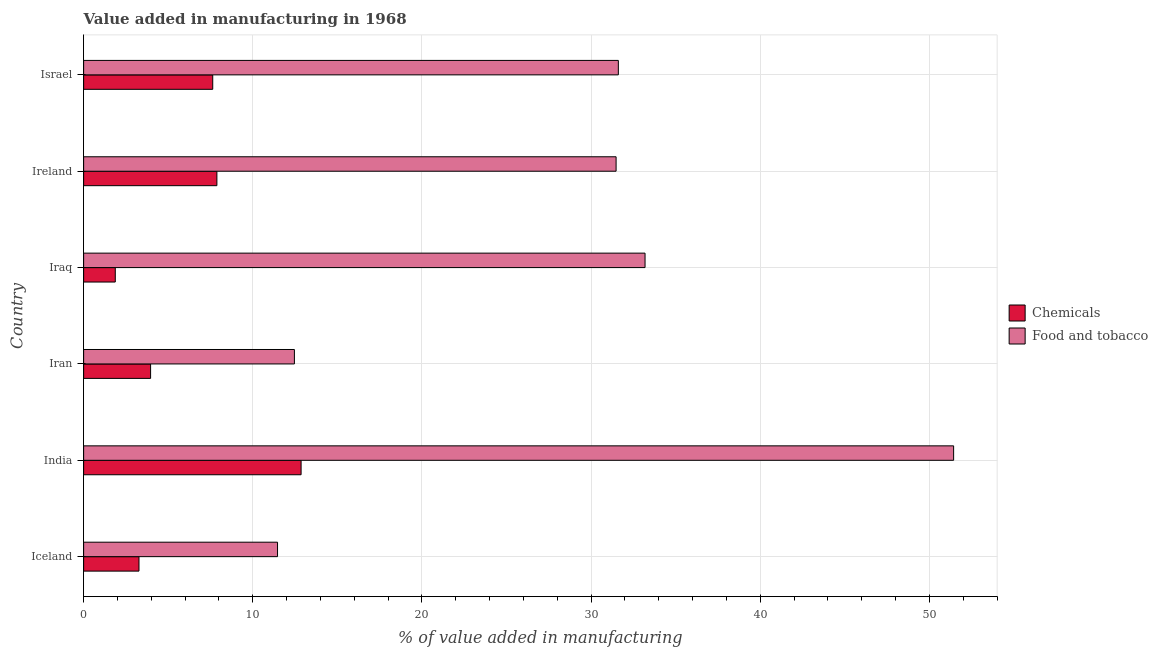How many different coloured bars are there?
Your answer should be very brief. 2. What is the label of the 1st group of bars from the top?
Keep it short and to the point. Israel. In how many cases, is the number of bars for a given country not equal to the number of legend labels?
Keep it short and to the point. 0. What is the value added by manufacturing food and tobacco in Israel?
Offer a very short reply. 31.61. Across all countries, what is the maximum value added by  manufacturing chemicals?
Give a very brief answer. 12.86. Across all countries, what is the minimum value added by  manufacturing chemicals?
Make the answer very short. 1.87. In which country was the value added by  manufacturing chemicals maximum?
Offer a terse response. India. What is the total value added by manufacturing food and tobacco in the graph?
Your answer should be very brief. 171.64. What is the difference between the value added by manufacturing food and tobacco in Iran and that in Israel?
Provide a succinct answer. -19.15. What is the difference between the value added by  manufacturing chemicals in Israel and the value added by manufacturing food and tobacco in Iceland?
Make the answer very short. -3.83. What is the average value added by  manufacturing chemicals per country?
Offer a very short reply. 6.25. What is the difference between the value added by manufacturing food and tobacco and value added by  manufacturing chemicals in Iran?
Your response must be concise. 8.5. What is the ratio of the value added by  manufacturing chemicals in India to that in Iraq?
Provide a succinct answer. 6.87. What is the difference between the highest and the second highest value added by  manufacturing chemicals?
Offer a very short reply. 4.98. What is the difference between the highest and the lowest value added by manufacturing food and tobacco?
Give a very brief answer. 39.97. In how many countries, is the value added by  manufacturing chemicals greater than the average value added by  manufacturing chemicals taken over all countries?
Offer a terse response. 3. Is the sum of the value added by manufacturing food and tobacco in Iceland and Israel greater than the maximum value added by  manufacturing chemicals across all countries?
Provide a succinct answer. Yes. What does the 2nd bar from the top in Iceland represents?
Give a very brief answer. Chemicals. What does the 2nd bar from the bottom in Israel represents?
Offer a very short reply. Food and tobacco. How many bars are there?
Provide a succinct answer. 12. Are all the bars in the graph horizontal?
Your answer should be very brief. Yes. How many countries are there in the graph?
Ensure brevity in your answer.  6. What is the difference between two consecutive major ticks on the X-axis?
Keep it short and to the point. 10. Are the values on the major ticks of X-axis written in scientific E-notation?
Offer a terse response. No. Does the graph contain any zero values?
Make the answer very short. No. Does the graph contain grids?
Your answer should be compact. Yes. Where does the legend appear in the graph?
Make the answer very short. Center right. How many legend labels are there?
Offer a very short reply. 2. How are the legend labels stacked?
Keep it short and to the point. Vertical. What is the title of the graph?
Ensure brevity in your answer.  Value added in manufacturing in 1968. What is the label or title of the X-axis?
Keep it short and to the point. % of value added in manufacturing. What is the label or title of the Y-axis?
Keep it short and to the point. Country. What is the % of value added in manufacturing in Chemicals in Iceland?
Make the answer very short. 3.27. What is the % of value added in manufacturing in Food and tobacco in Iceland?
Your answer should be compact. 11.46. What is the % of value added in manufacturing of Chemicals in India?
Give a very brief answer. 12.86. What is the % of value added in manufacturing of Food and tobacco in India?
Your answer should be compact. 51.43. What is the % of value added in manufacturing in Chemicals in Iran?
Provide a short and direct response. 3.96. What is the % of value added in manufacturing in Food and tobacco in Iran?
Make the answer very short. 12.46. What is the % of value added in manufacturing of Chemicals in Iraq?
Make the answer very short. 1.87. What is the % of value added in manufacturing in Food and tobacco in Iraq?
Provide a succinct answer. 33.19. What is the % of value added in manufacturing of Chemicals in Ireland?
Give a very brief answer. 7.88. What is the % of value added in manufacturing in Food and tobacco in Ireland?
Provide a short and direct response. 31.48. What is the % of value added in manufacturing of Chemicals in Israel?
Offer a very short reply. 7.63. What is the % of value added in manufacturing of Food and tobacco in Israel?
Provide a succinct answer. 31.61. Across all countries, what is the maximum % of value added in manufacturing of Chemicals?
Your response must be concise. 12.86. Across all countries, what is the maximum % of value added in manufacturing in Food and tobacco?
Offer a very short reply. 51.43. Across all countries, what is the minimum % of value added in manufacturing of Chemicals?
Provide a succinct answer. 1.87. Across all countries, what is the minimum % of value added in manufacturing of Food and tobacco?
Ensure brevity in your answer.  11.46. What is the total % of value added in manufacturing in Chemicals in the graph?
Ensure brevity in your answer.  37.47. What is the total % of value added in manufacturing in Food and tobacco in the graph?
Provide a short and direct response. 171.64. What is the difference between the % of value added in manufacturing in Chemicals in Iceland and that in India?
Your response must be concise. -9.58. What is the difference between the % of value added in manufacturing of Food and tobacco in Iceland and that in India?
Give a very brief answer. -39.97. What is the difference between the % of value added in manufacturing in Chemicals in Iceland and that in Iran?
Your answer should be very brief. -0.69. What is the difference between the % of value added in manufacturing of Food and tobacco in Iceland and that in Iran?
Your response must be concise. -1. What is the difference between the % of value added in manufacturing in Chemicals in Iceland and that in Iraq?
Your answer should be very brief. 1.4. What is the difference between the % of value added in manufacturing in Food and tobacco in Iceland and that in Iraq?
Give a very brief answer. -21.73. What is the difference between the % of value added in manufacturing in Chemicals in Iceland and that in Ireland?
Keep it short and to the point. -4.61. What is the difference between the % of value added in manufacturing of Food and tobacco in Iceland and that in Ireland?
Offer a terse response. -20.02. What is the difference between the % of value added in manufacturing of Chemicals in Iceland and that in Israel?
Your answer should be compact. -4.36. What is the difference between the % of value added in manufacturing of Food and tobacco in Iceland and that in Israel?
Give a very brief answer. -20.15. What is the difference between the % of value added in manufacturing of Chemicals in India and that in Iran?
Your response must be concise. 8.9. What is the difference between the % of value added in manufacturing in Food and tobacco in India and that in Iran?
Make the answer very short. 38.97. What is the difference between the % of value added in manufacturing in Chemicals in India and that in Iraq?
Give a very brief answer. 10.98. What is the difference between the % of value added in manufacturing in Food and tobacco in India and that in Iraq?
Offer a very short reply. 18.24. What is the difference between the % of value added in manufacturing in Chemicals in India and that in Ireland?
Offer a terse response. 4.98. What is the difference between the % of value added in manufacturing of Food and tobacco in India and that in Ireland?
Offer a very short reply. 19.95. What is the difference between the % of value added in manufacturing in Chemicals in India and that in Israel?
Your answer should be very brief. 5.22. What is the difference between the % of value added in manufacturing of Food and tobacco in India and that in Israel?
Provide a succinct answer. 19.82. What is the difference between the % of value added in manufacturing of Chemicals in Iran and that in Iraq?
Ensure brevity in your answer.  2.09. What is the difference between the % of value added in manufacturing in Food and tobacco in Iran and that in Iraq?
Ensure brevity in your answer.  -20.73. What is the difference between the % of value added in manufacturing of Chemicals in Iran and that in Ireland?
Provide a short and direct response. -3.92. What is the difference between the % of value added in manufacturing of Food and tobacco in Iran and that in Ireland?
Keep it short and to the point. -19.02. What is the difference between the % of value added in manufacturing of Chemicals in Iran and that in Israel?
Give a very brief answer. -3.67. What is the difference between the % of value added in manufacturing in Food and tobacco in Iran and that in Israel?
Offer a terse response. -19.15. What is the difference between the % of value added in manufacturing of Chemicals in Iraq and that in Ireland?
Your response must be concise. -6.01. What is the difference between the % of value added in manufacturing of Food and tobacco in Iraq and that in Ireland?
Ensure brevity in your answer.  1.71. What is the difference between the % of value added in manufacturing of Chemicals in Iraq and that in Israel?
Provide a succinct answer. -5.76. What is the difference between the % of value added in manufacturing of Food and tobacco in Iraq and that in Israel?
Keep it short and to the point. 1.58. What is the difference between the % of value added in manufacturing of Chemicals in Ireland and that in Israel?
Make the answer very short. 0.25. What is the difference between the % of value added in manufacturing of Food and tobacco in Ireland and that in Israel?
Your answer should be very brief. -0.13. What is the difference between the % of value added in manufacturing in Chemicals in Iceland and the % of value added in manufacturing in Food and tobacco in India?
Provide a short and direct response. -48.16. What is the difference between the % of value added in manufacturing of Chemicals in Iceland and the % of value added in manufacturing of Food and tobacco in Iran?
Give a very brief answer. -9.19. What is the difference between the % of value added in manufacturing of Chemicals in Iceland and the % of value added in manufacturing of Food and tobacco in Iraq?
Ensure brevity in your answer.  -29.92. What is the difference between the % of value added in manufacturing in Chemicals in Iceland and the % of value added in manufacturing in Food and tobacco in Ireland?
Provide a short and direct response. -28.21. What is the difference between the % of value added in manufacturing of Chemicals in Iceland and the % of value added in manufacturing of Food and tobacco in Israel?
Make the answer very short. -28.34. What is the difference between the % of value added in manufacturing of Chemicals in India and the % of value added in manufacturing of Food and tobacco in Iran?
Your response must be concise. 0.4. What is the difference between the % of value added in manufacturing of Chemicals in India and the % of value added in manufacturing of Food and tobacco in Iraq?
Provide a succinct answer. -20.33. What is the difference between the % of value added in manufacturing in Chemicals in India and the % of value added in manufacturing in Food and tobacco in Ireland?
Your answer should be very brief. -18.62. What is the difference between the % of value added in manufacturing of Chemicals in India and the % of value added in manufacturing of Food and tobacco in Israel?
Keep it short and to the point. -18.76. What is the difference between the % of value added in manufacturing in Chemicals in Iran and the % of value added in manufacturing in Food and tobacco in Iraq?
Make the answer very short. -29.23. What is the difference between the % of value added in manufacturing in Chemicals in Iran and the % of value added in manufacturing in Food and tobacco in Ireland?
Keep it short and to the point. -27.52. What is the difference between the % of value added in manufacturing of Chemicals in Iran and the % of value added in manufacturing of Food and tobacco in Israel?
Your answer should be compact. -27.65. What is the difference between the % of value added in manufacturing of Chemicals in Iraq and the % of value added in manufacturing of Food and tobacco in Ireland?
Your response must be concise. -29.61. What is the difference between the % of value added in manufacturing of Chemicals in Iraq and the % of value added in manufacturing of Food and tobacco in Israel?
Your answer should be compact. -29.74. What is the difference between the % of value added in manufacturing of Chemicals in Ireland and the % of value added in manufacturing of Food and tobacco in Israel?
Your response must be concise. -23.73. What is the average % of value added in manufacturing in Chemicals per country?
Make the answer very short. 6.25. What is the average % of value added in manufacturing in Food and tobacco per country?
Make the answer very short. 28.61. What is the difference between the % of value added in manufacturing in Chemicals and % of value added in manufacturing in Food and tobacco in Iceland?
Provide a succinct answer. -8.19. What is the difference between the % of value added in manufacturing of Chemicals and % of value added in manufacturing of Food and tobacco in India?
Offer a terse response. -38.58. What is the difference between the % of value added in manufacturing of Chemicals and % of value added in manufacturing of Food and tobacco in Iran?
Give a very brief answer. -8.5. What is the difference between the % of value added in manufacturing in Chemicals and % of value added in manufacturing in Food and tobacco in Iraq?
Provide a succinct answer. -31.32. What is the difference between the % of value added in manufacturing in Chemicals and % of value added in manufacturing in Food and tobacco in Ireland?
Offer a very short reply. -23.6. What is the difference between the % of value added in manufacturing of Chemicals and % of value added in manufacturing of Food and tobacco in Israel?
Offer a very short reply. -23.98. What is the ratio of the % of value added in manufacturing in Chemicals in Iceland to that in India?
Keep it short and to the point. 0.25. What is the ratio of the % of value added in manufacturing of Food and tobacco in Iceland to that in India?
Make the answer very short. 0.22. What is the ratio of the % of value added in manufacturing in Chemicals in Iceland to that in Iran?
Offer a very short reply. 0.83. What is the ratio of the % of value added in manufacturing of Food and tobacco in Iceland to that in Iran?
Keep it short and to the point. 0.92. What is the ratio of the % of value added in manufacturing in Chemicals in Iceland to that in Iraq?
Give a very brief answer. 1.75. What is the ratio of the % of value added in manufacturing of Food and tobacco in Iceland to that in Iraq?
Provide a short and direct response. 0.35. What is the ratio of the % of value added in manufacturing in Chemicals in Iceland to that in Ireland?
Your answer should be compact. 0.42. What is the ratio of the % of value added in manufacturing of Food and tobacco in Iceland to that in Ireland?
Give a very brief answer. 0.36. What is the ratio of the % of value added in manufacturing in Chemicals in Iceland to that in Israel?
Provide a succinct answer. 0.43. What is the ratio of the % of value added in manufacturing of Food and tobacco in Iceland to that in Israel?
Give a very brief answer. 0.36. What is the ratio of the % of value added in manufacturing in Chemicals in India to that in Iran?
Keep it short and to the point. 3.25. What is the ratio of the % of value added in manufacturing in Food and tobacco in India to that in Iran?
Your response must be concise. 4.13. What is the ratio of the % of value added in manufacturing of Chemicals in India to that in Iraq?
Offer a terse response. 6.87. What is the ratio of the % of value added in manufacturing of Food and tobacco in India to that in Iraq?
Offer a terse response. 1.55. What is the ratio of the % of value added in manufacturing in Chemicals in India to that in Ireland?
Offer a terse response. 1.63. What is the ratio of the % of value added in manufacturing of Food and tobacco in India to that in Ireland?
Ensure brevity in your answer.  1.63. What is the ratio of the % of value added in manufacturing of Chemicals in India to that in Israel?
Offer a very short reply. 1.68. What is the ratio of the % of value added in manufacturing in Food and tobacco in India to that in Israel?
Your answer should be compact. 1.63. What is the ratio of the % of value added in manufacturing in Chemicals in Iran to that in Iraq?
Make the answer very short. 2.12. What is the ratio of the % of value added in manufacturing in Food and tobacco in Iran to that in Iraq?
Ensure brevity in your answer.  0.38. What is the ratio of the % of value added in manufacturing of Chemicals in Iran to that in Ireland?
Ensure brevity in your answer.  0.5. What is the ratio of the % of value added in manufacturing of Food and tobacco in Iran to that in Ireland?
Provide a succinct answer. 0.4. What is the ratio of the % of value added in manufacturing in Chemicals in Iran to that in Israel?
Ensure brevity in your answer.  0.52. What is the ratio of the % of value added in manufacturing in Food and tobacco in Iran to that in Israel?
Your answer should be compact. 0.39. What is the ratio of the % of value added in manufacturing of Chemicals in Iraq to that in Ireland?
Your response must be concise. 0.24. What is the ratio of the % of value added in manufacturing of Food and tobacco in Iraq to that in Ireland?
Your answer should be very brief. 1.05. What is the ratio of the % of value added in manufacturing of Chemicals in Iraq to that in Israel?
Ensure brevity in your answer.  0.25. What is the ratio of the % of value added in manufacturing in Chemicals in Ireland to that in Israel?
Offer a terse response. 1.03. What is the difference between the highest and the second highest % of value added in manufacturing of Chemicals?
Your answer should be compact. 4.98. What is the difference between the highest and the second highest % of value added in manufacturing of Food and tobacco?
Make the answer very short. 18.24. What is the difference between the highest and the lowest % of value added in manufacturing in Chemicals?
Your answer should be very brief. 10.98. What is the difference between the highest and the lowest % of value added in manufacturing in Food and tobacco?
Offer a very short reply. 39.97. 